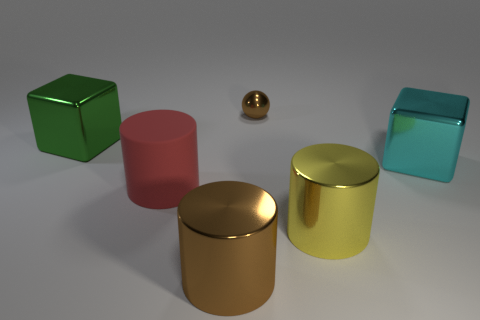Is there a big green cube that has the same material as the big brown cylinder?
Ensure brevity in your answer.  Yes. What size is the metal cylinder that is the same color as the metal sphere?
Offer a terse response. Large. There is a cylinder on the left side of the metallic cylinder that is in front of the yellow thing; what is it made of?
Provide a succinct answer. Rubber. What number of large shiny cylinders are the same color as the small thing?
Provide a short and direct response. 1. What size is the green block that is the same material as the small brown thing?
Provide a short and direct response. Large. The brown thing in front of the tiny brown sphere has what shape?
Your answer should be compact. Cylinder. There is a block that is on the right side of the brown metallic object in front of the small metallic thing; what number of big red things are in front of it?
Your answer should be compact. 1. Are there an equal number of small brown spheres behind the small metal sphere and small purple cubes?
Offer a terse response. Yes. How many blocks are either yellow metal things or red objects?
Offer a terse response. 0. Are there the same number of big cylinders left of the brown metal cylinder and small shiny balls on the right side of the yellow cylinder?
Offer a very short reply. No. 